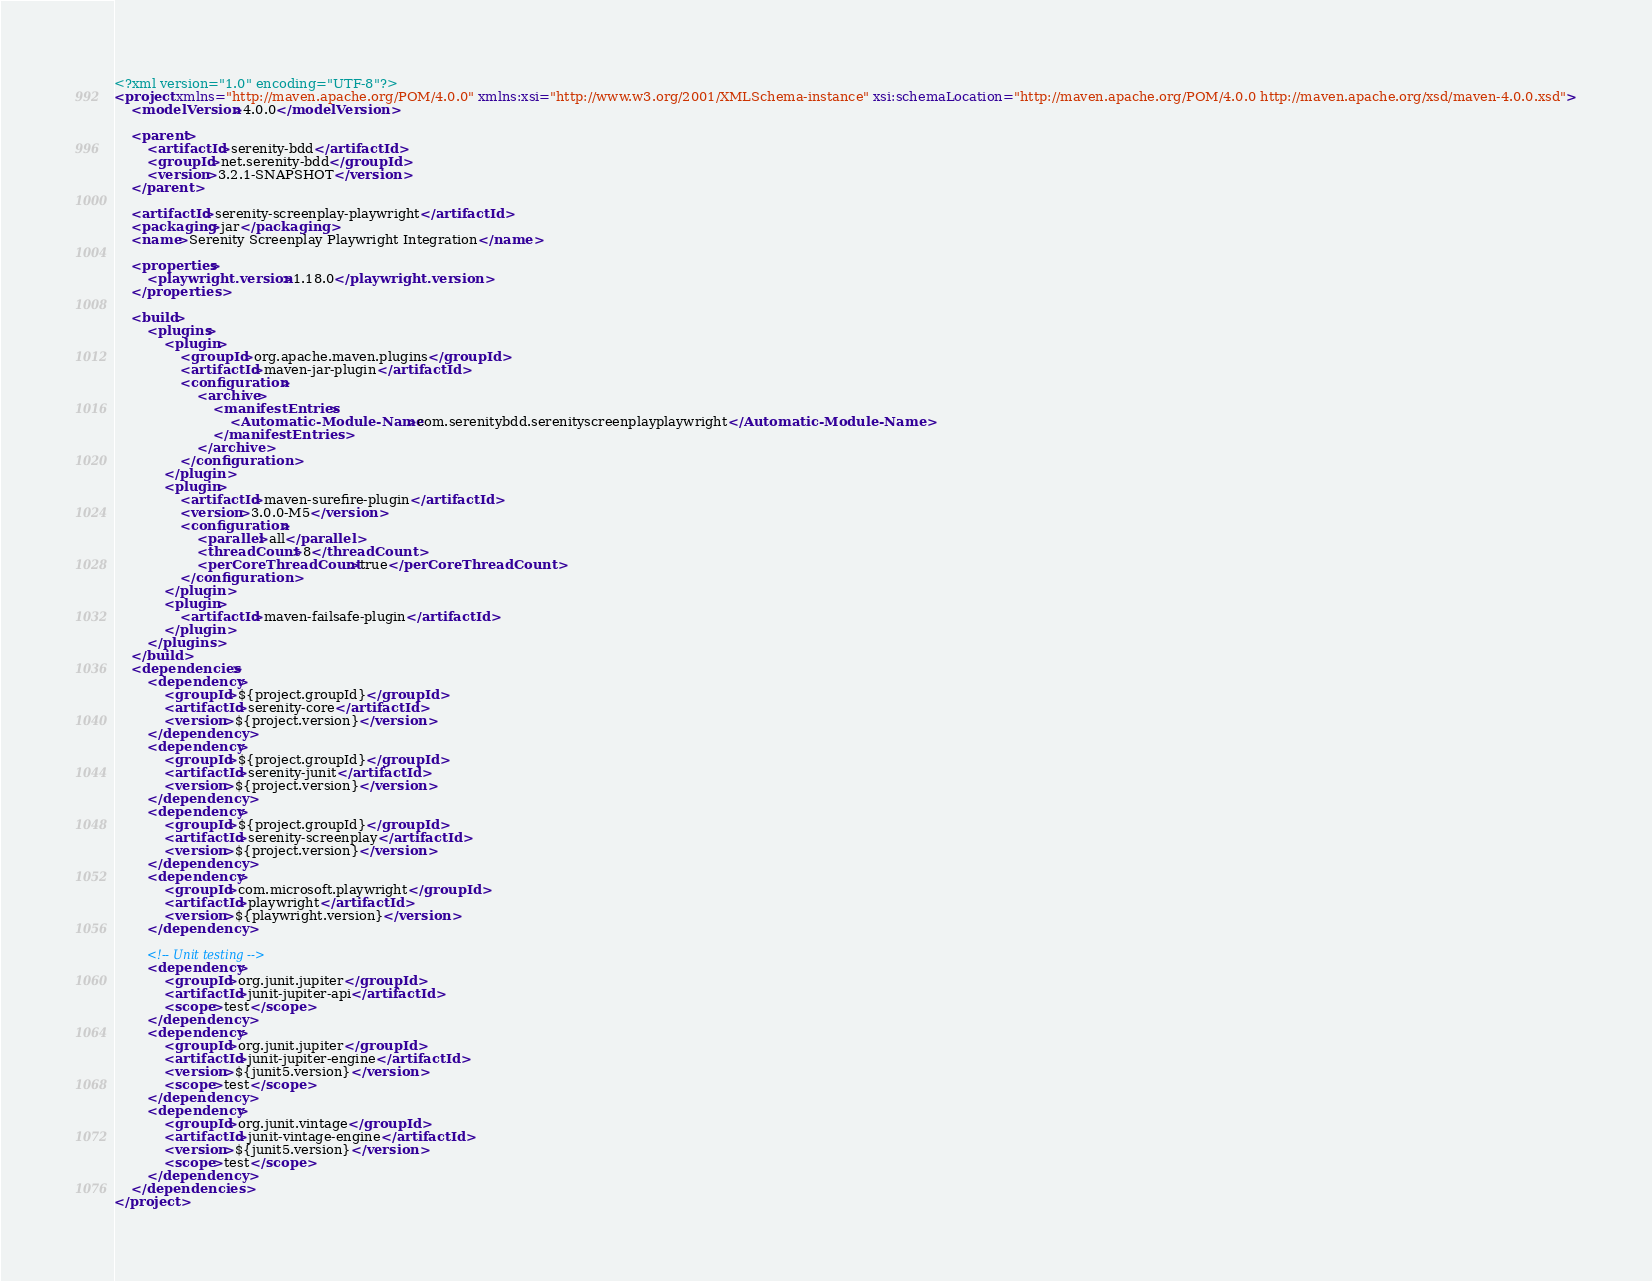Convert code to text. <code><loc_0><loc_0><loc_500><loc_500><_XML_><?xml version="1.0" encoding="UTF-8"?>
<project xmlns="http://maven.apache.org/POM/4.0.0" xmlns:xsi="http://www.w3.org/2001/XMLSchema-instance" xsi:schemaLocation="http://maven.apache.org/POM/4.0.0 http://maven.apache.org/xsd/maven-4.0.0.xsd">
    <modelVersion>4.0.0</modelVersion>

    <parent>
        <artifactId>serenity-bdd</artifactId>
        <groupId>net.serenity-bdd</groupId>
        <version>3.2.1-SNAPSHOT</version>
    </parent>

    <artifactId>serenity-screenplay-playwright</artifactId>
    <packaging>jar</packaging>
    <name>Serenity Screenplay Playwright Integration</name>

    <properties>
        <playwright.version>1.18.0</playwright.version>
    </properties>

    <build>
        <plugins>
            <plugin>
                <groupId>org.apache.maven.plugins</groupId>
                <artifactId>maven-jar-plugin</artifactId>
                <configuration>
                    <archive>
                        <manifestEntries>
                            <Automatic-Module-Name>com.serenitybdd.serenityscreenplayplaywright</Automatic-Module-Name>
                        </manifestEntries>
                    </archive>
                </configuration>
            </plugin>
            <plugin>
                <artifactId>maven-surefire-plugin</artifactId>
                <version>3.0.0-M5</version>
                <configuration>
                    <parallel>all</parallel>
                    <threadCount>8</threadCount>
                    <perCoreThreadCount>true</perCoreThreadCount>
                </configuration>
            </plugin>
            <plugin>
                <artifactId>maven-failsafe-plugin</artifactId>
            </plugin>
        </plugins>
    </build>
    <dependencies>
        <dependency>
            <groupId>${project.groupId}</groupId>
            <artifactId>serenity-core</artifactId>
            <version>${project.version}</version>
        </dependency>
        <dependency>
            <groupId>${project.groupId}</groupId>
            <artifactId>serenity-junit</artifactId>
            <version>${project.version}</version>
        </dependency>
        <dependency>
            <groupId>${project.groupId}</groupId>
            <artifactId>serenity-screenplay</artifactId>
            <version>${project.version}</version>
        </dependency>
        <dependency>
            <groupId>com.microsoft.playwright</groupId>
            <artifactId>playwright</artifactId>
            <version>${playwright.version}</version>
        </dependency>

        <!-- Unit testing -->
        <dependency>
            <groupId>org.junit.jupiter</groupId>
            <artifactId>junit-jupiter-api</artifactId>
            <scope>test</scope>
        </dependency>
        <dependency>
            <groupId>org.junit.jupiter</groupId>
            <artifactId>junit-jupiter-engine</artifactId>
            <version>${junit5.version}</version>
            <scope>test</scope>
        </dependency>
        <dependency>
            <groupId>org.junit.vintage</groupId>
            <artifactId>junit-vintage-engine</artifactId>
            <version>${junit5.version}</version>
            <scope>test</scope>
        </dependency>
    </dependencies>
</project>
</code> 